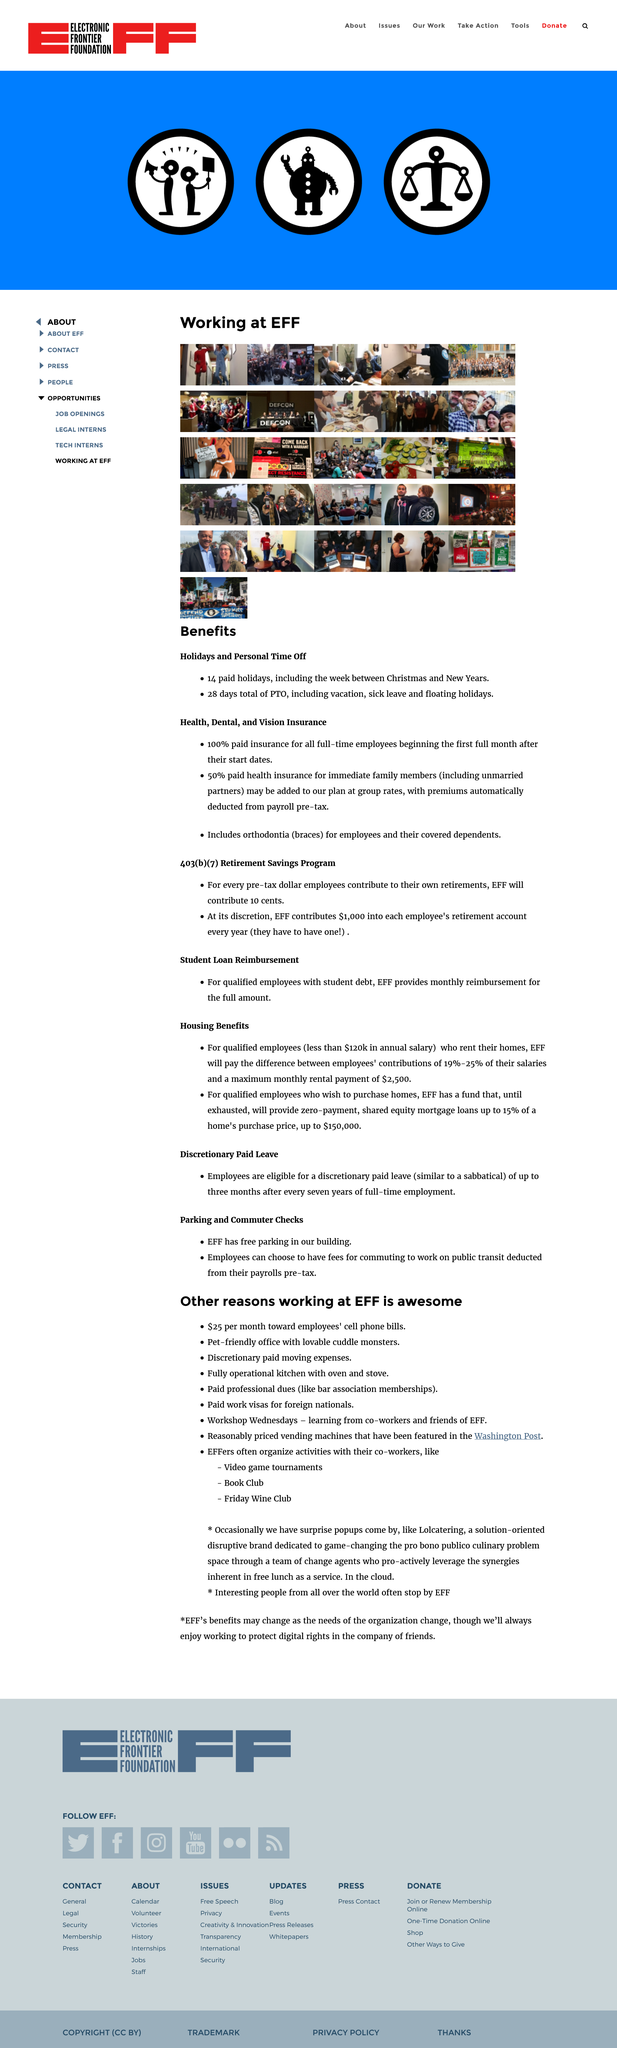Indicate a few pertinent items in this graphic. Working at the Electronic Frontier Foundation is awesome because employees can receive up to $25 per month towards their cell phone bills. The workshops are held on Wednesdays. Yes, their office is pet-friendly. The Electronic Frontier Foundation (EFF) provides assistance to qualified employees who are struggling to pay their rent, regardless of their annual salary. If an employee's contribution towards their rent is less than 25% of their salary and their maximum monthly rent is $2,500 or less, EFF will pay the difference to help them meet their rental obligations. Sick leave is included in Personal Time Off (PTO). 